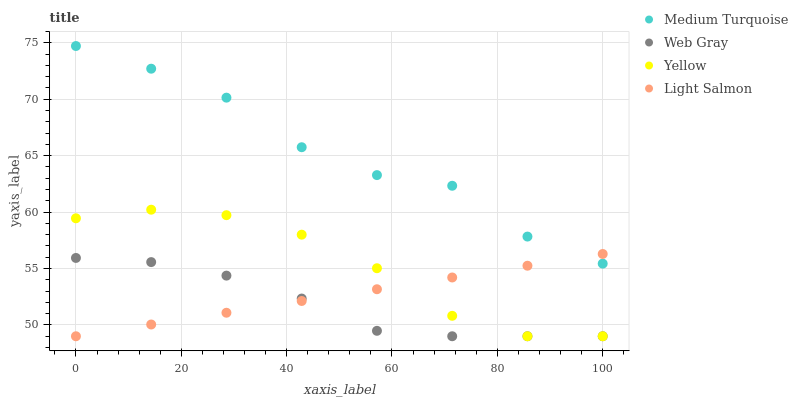Does Web Gray have the minimum area under the curve?
Answer yes or no. Yes. Does Medium Turquoise have the maximum area under the curve?
Answer yes or no. Yes. Does Yellow have the minimum area under the curve?
Answer yes or no. No. Does Yellow have the maximum area under the curve?
Answer yes or no. No. Is Light Salmon the smoothest?
Answer yes or no. Yes. Is Medium Turquoise the roughest?
Answer yes or no. Yes. Is Web Gray the smoothest?
Answer yes or no. No. Is Web Gray the roughest?
Answer yes or no. No. Does Light Salmon have the lowest value?
Answer yes or no. Yes. Does Medium Turquoise have the lowest value?
Answer yes or no. No. Does Medium Turquoise have the highest value?
Answer yes or no. Yes. Does Yellow have the highest value?
Answer yes or no. No. Is Web Gray less than Medium Turquoise?
Answer yes or no. Yes. Is Medium Turquoise greater than Web Gray?
Answer yes or no. Yes. Does Medium Turquoise intersect Light Salmon?
Answer yes or no. Yes. Is Medium Turquoise less than Light Salmon?
Answer yes or no. No. Is Medium Turquoise greater than Light Salmon?
Answer yes or no. No. Does Web Gray intersect Medium Turquoise?
Answer yes or no. No. 